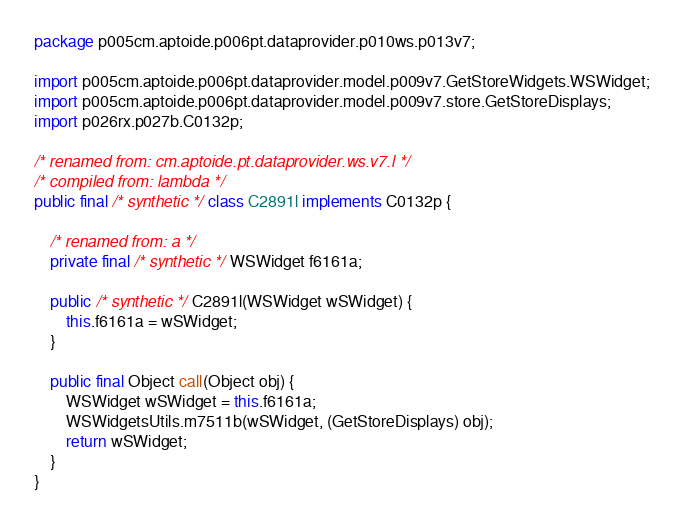Convert code to text. <code><loc_0><loc_0><loc_500><loc_500><_Java_>package p005cm.aptoide.p006pt.dataprovider.p010ws.p013v7;

import p005cm.aptoide.p006pt.dataprovider.model.p009v7.GetStoreWidgets.WSWidget;
import p005cm.aptoide.p006pt.dataprovider.model.p009v7.store.GetStoreDisplays;
import p026rx.p027b.C0132p;

/* renamed from: cm.aptoide.pt.dataprovider.ws.v7.l */
/* compiled from: lambda */
public final /* synthetic */ class C2891l implements C0132p {

    /* renamed from: a */
    private final /* synthetic */ WSWidget f6161a;

    public /* synthetic */ C2891l(WSWidget wSWidget) {
        this.f6161a = wSWidget;
    }

    public final Object call(Object obj) {
        WSWidget wSWidget = this.f6161a;
        WSWidgetsUtils.m7511b(wSWidget, (GetStoreDisplays) obj);
        return wSWidget;
    }
}
</code> 